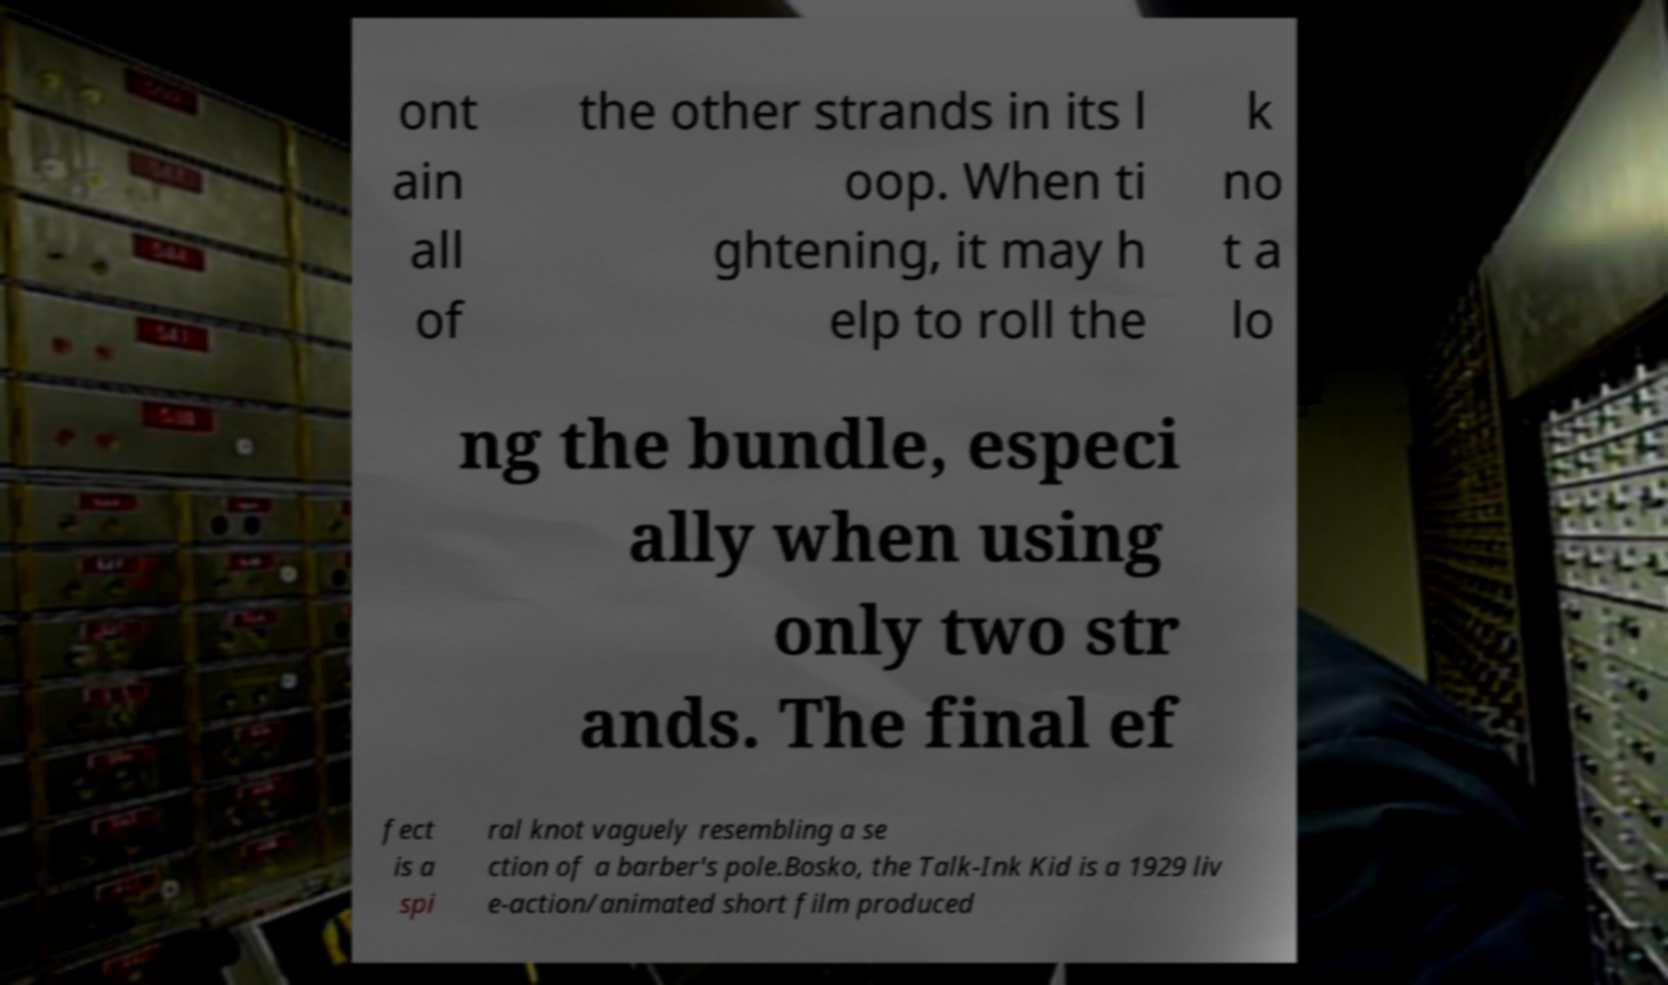Could you assist in decoding the text presented in this image and type it out clearly? ont ain all of the other strands in its l oop. When ti ghtening, it may h elp to roll the k no t a lo ng the bundle, especi ally when using only two str ands. The final ef fect is a spi ral knot vaguely resembling a se ction of a barber's pole.Bosko, the Talk-Ink Kid is a 1929 liv e-action/animated short film produced 